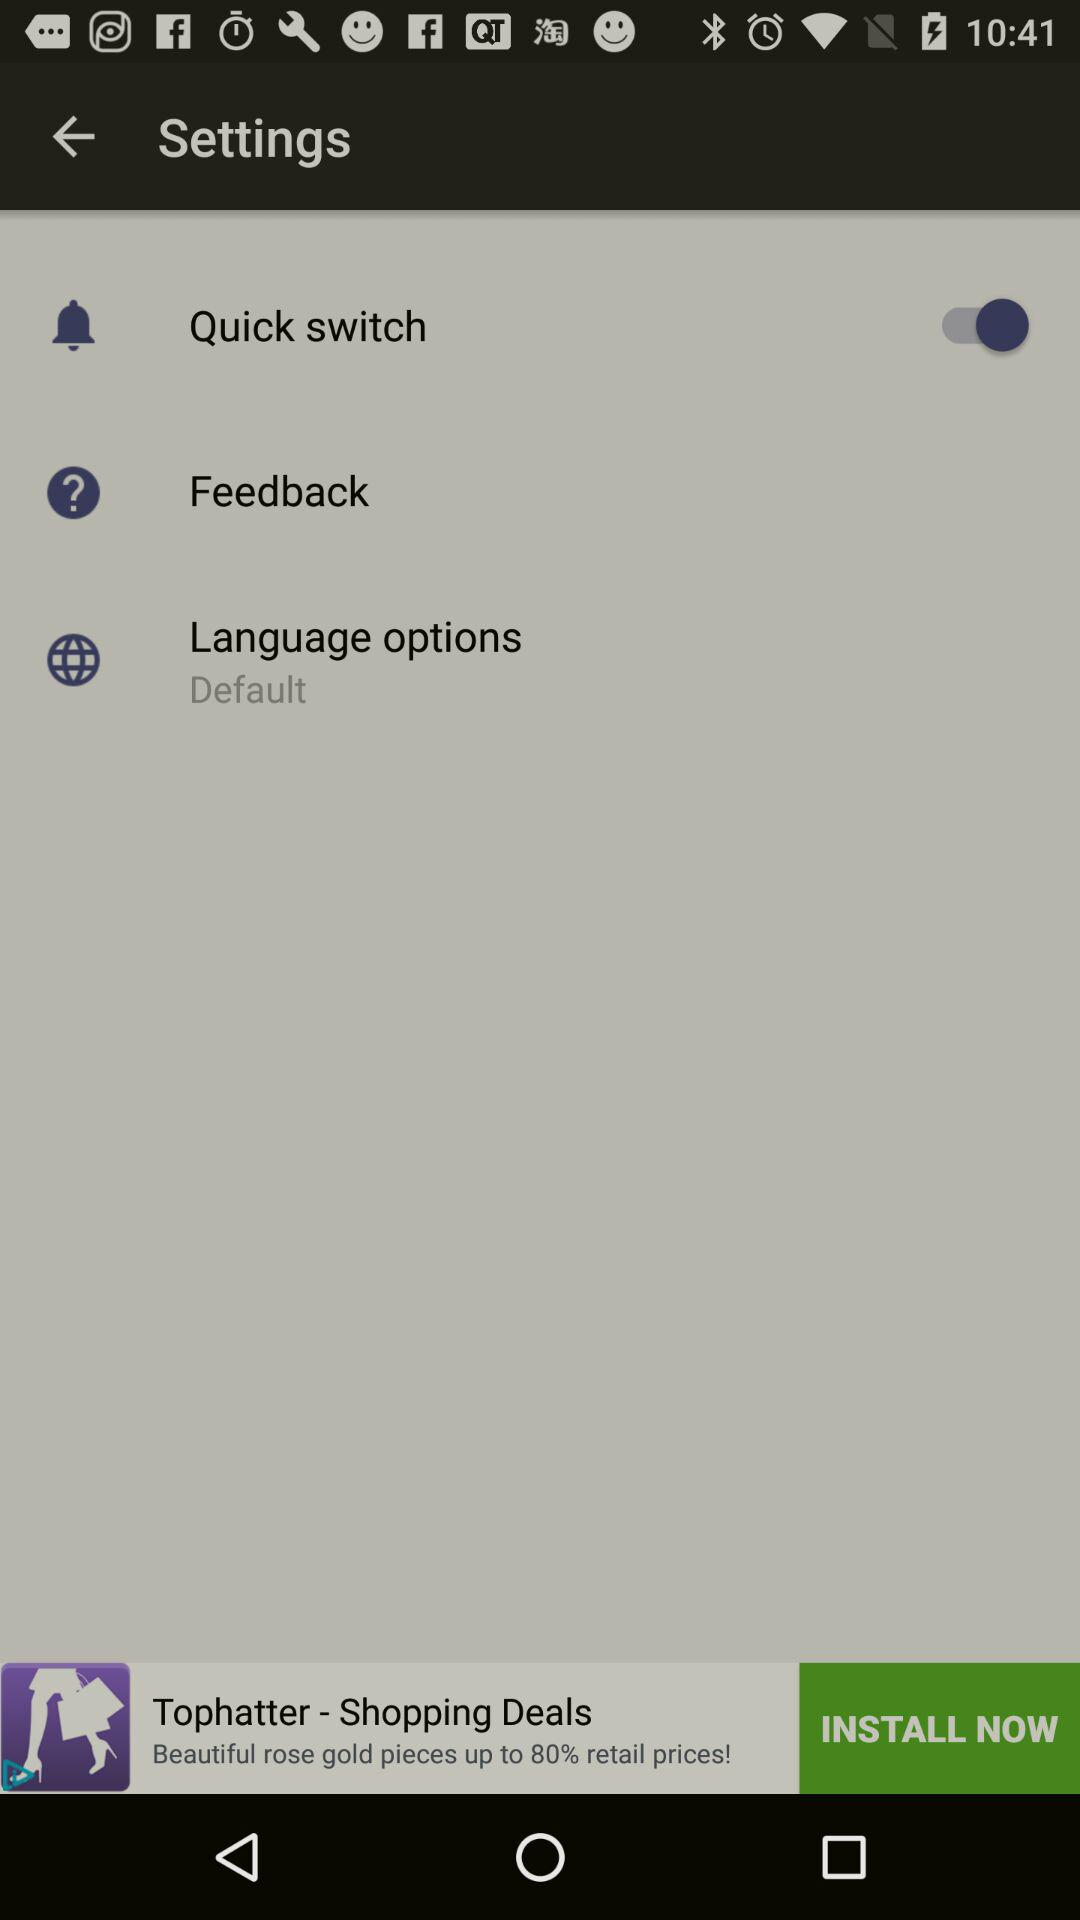What language option is selected? The selected language option is default. 